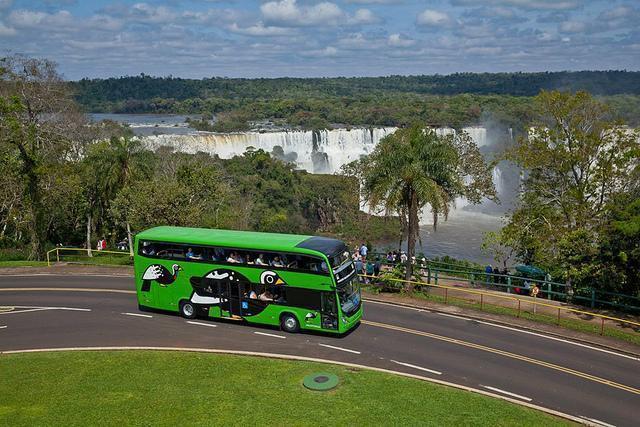Where are the people on the bus going?
Make your selection and explain in format: 'Answer: answer
Rationale: rationale.'
Options: To school, home, to work, sightseeing. Answer: sightseeing.
Rationale: Double decker buses are taken by tourists. tourists come to see the sights. 